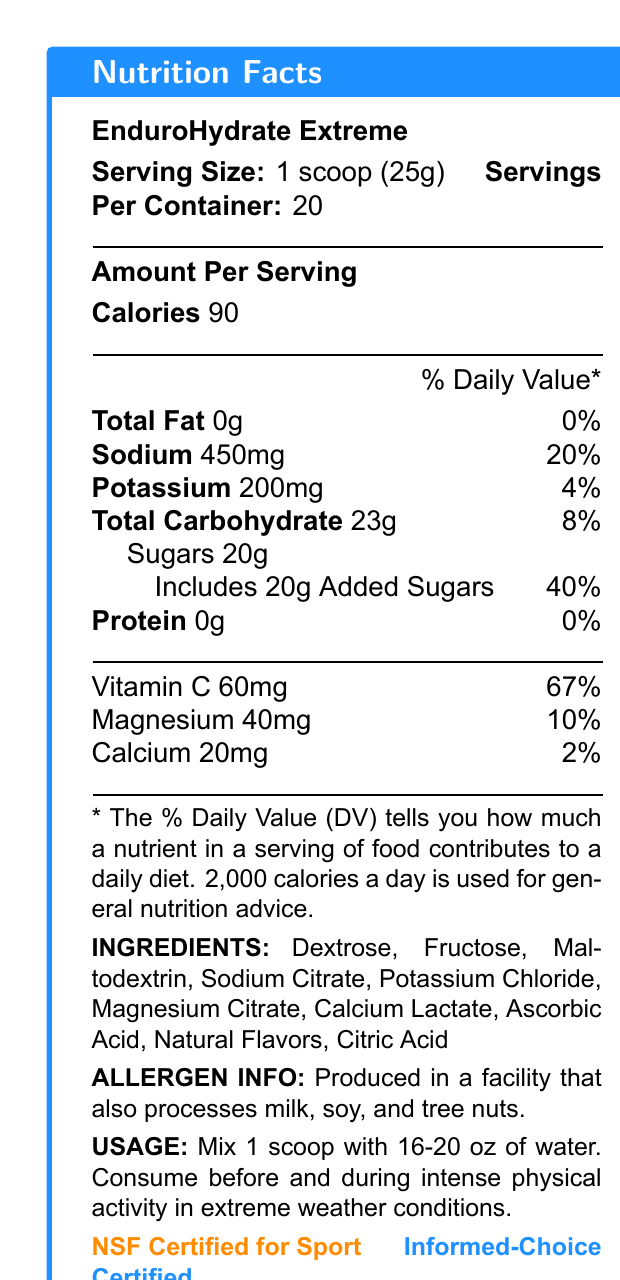what is the serving size? The serving size is listed at the top of the document as "1 scoop (25g)".
Answer: 1 scoop (25g) how many calories are in one serving of EnduroHydrate Extreme? The amount of calories per serving is listed under the "Amount Per Serving" section.
Answer: 90 calories how much sodium is in one serving? The sodium content is listed under the "Amount Per Serving" section with a value of 450mg.
Answer: 450mg what is the daily value percentage for magnesium? The daily value percentage for magnesium (40mg) is listed as 10%.
Answer: 10% what are the ingredients in EnduroHydrate Extreme? The ingredients are listed towards the bottom of the document in the "INGREDIENTS" section.
Answer: Dextrose, Fructose, Maltodextrin, Sodium Citrate, Potassium Chloride, Magnesium Citrate, Calcium Lactate, Ascorbic Acid, Natural Flavors, Citric Acid which vitamin has the highest daily value percentage? A. Vitamin C B. Magnesium C. Calcium D. Protein Vitamin C has a daily value percentage of 67%, which is the highest among the listed nutrients.
Answer: A. Vitamin C how many carbohydrates are in one serving? A. 10g B. 15g C. 20g D. 23g The "Total Carbohydrate" amount per serving is listed as 23g under the "Amount Per Serving" section.
Answer: D. 23g is this product suitable for athletes? The product description specifically mentions that it is formulated for athletes competing in high-intensity sports.
Answer: Yes describe the main idea of this document. The document gives detailed information on serving size, ingredients, nutrition facts, usage instructions, allergen information, and certifications.
Answer: This document provides the nutrition facts and product details for EnduroHydrate Extreme, a hydration drink mix designed for athletes in extreme weather conditions. what are the key benefits of using EnduroHydrate Extreme? The key benefits are listed in the "key benefits" section of the product description.
Answer: Rapid electrolyte replenishment, Enhanced fluid retention, Improved heat tolerance, Sustained energy release, Supports cognitive function during prolonged exertion does this product contain dairy? The document only states that the product is produced in a facility that also processes milk, soy, and tree nuts, but does not specifically mention if it contains dairy.
Answer: Cannot be determined 